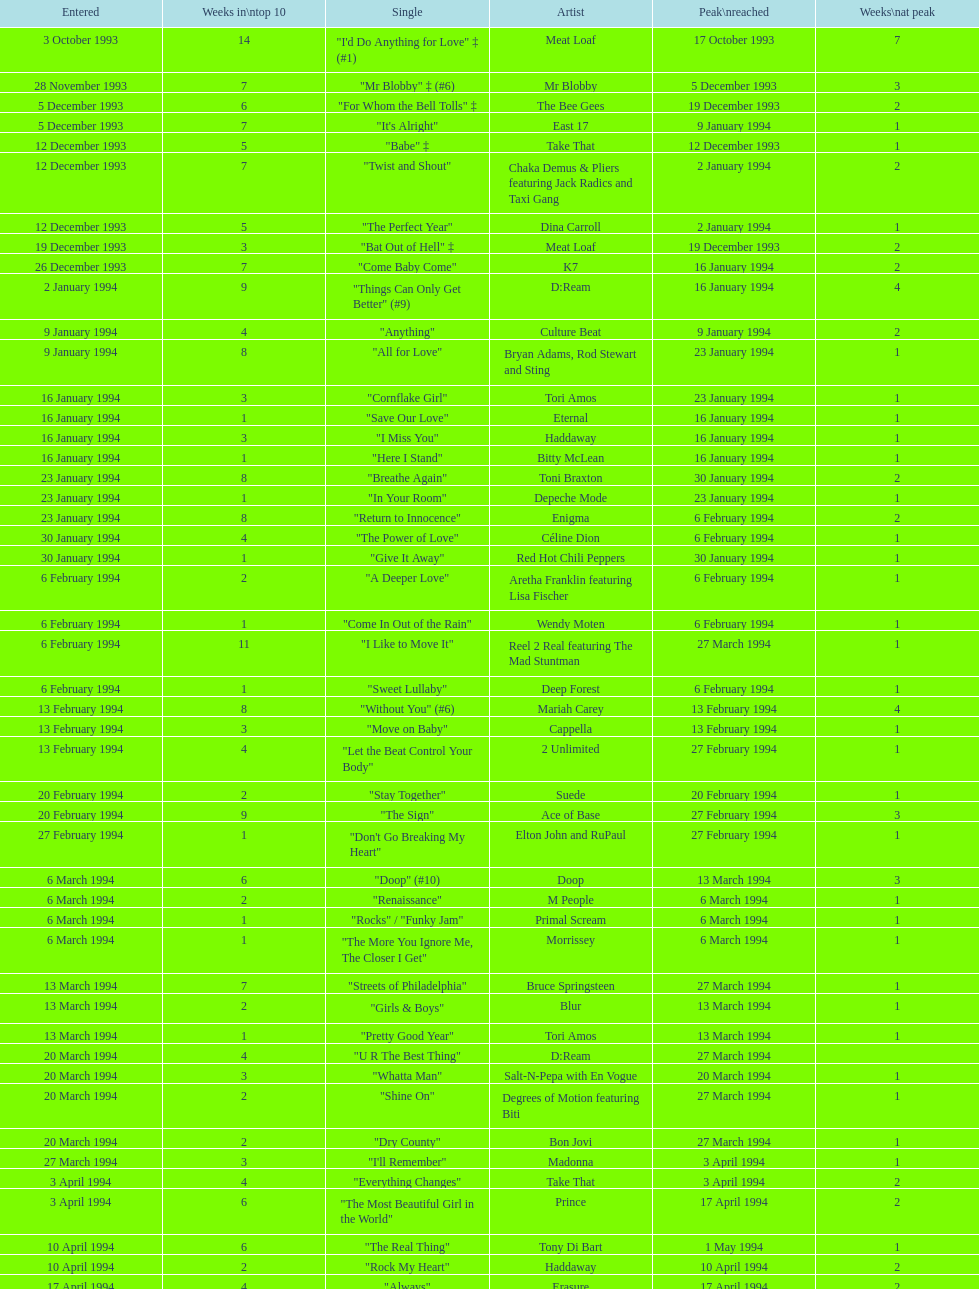Which artist only has its single entered on 2 january 1994? D:Ream. 